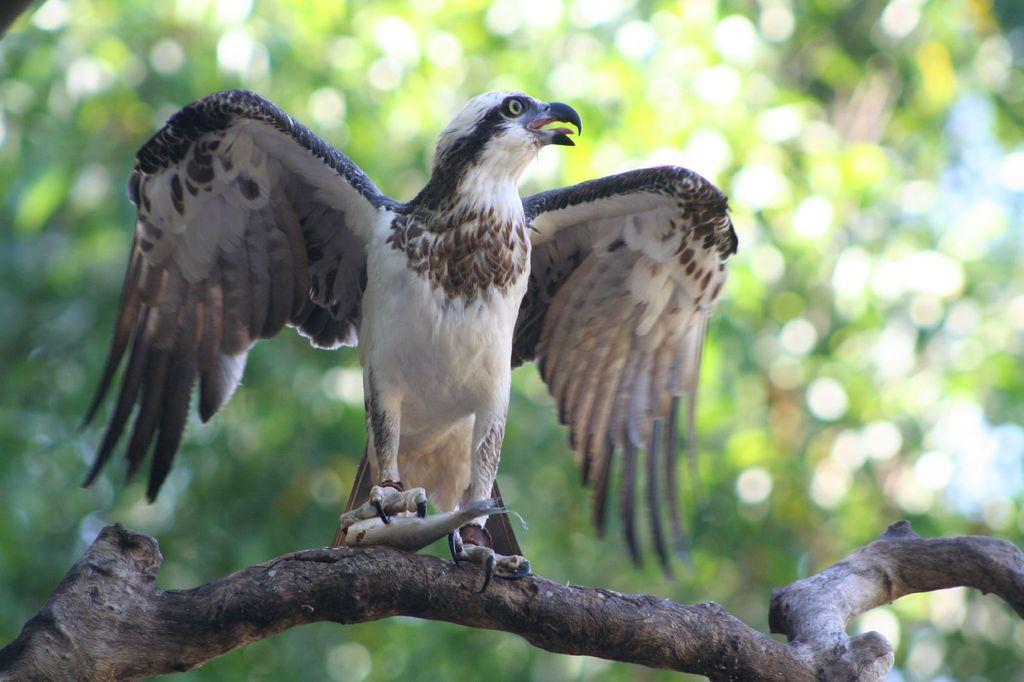Could you give a brief overview of what you see in this image? In this image I can see a bird is sitting on the branch of a tree and holding a fish. In the background I can see trees. This image is taken during a day. 